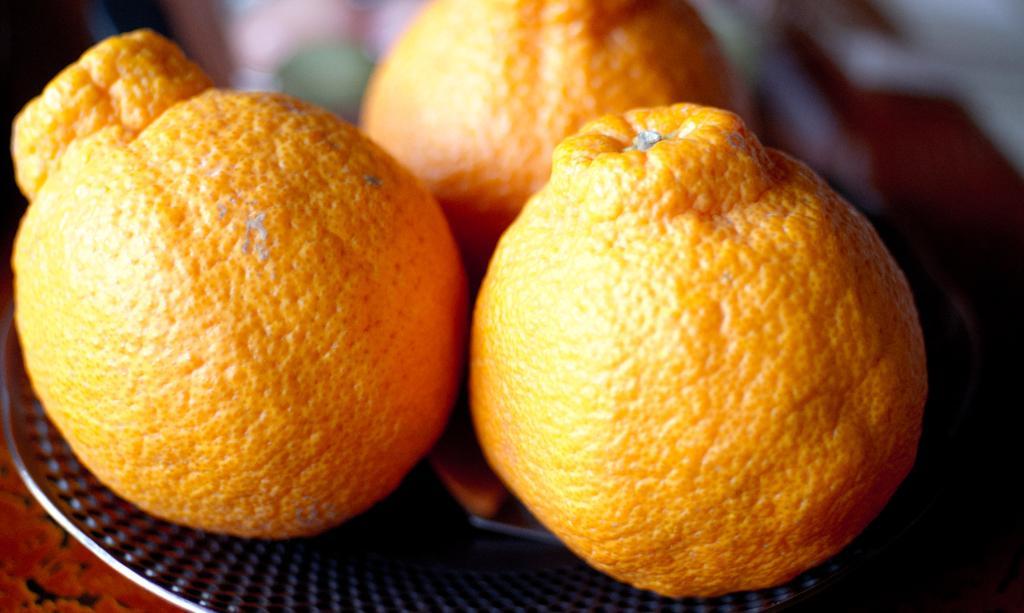Could you give a brief overview of what you see in this image? In the center of the image we can see oranges on plate. 